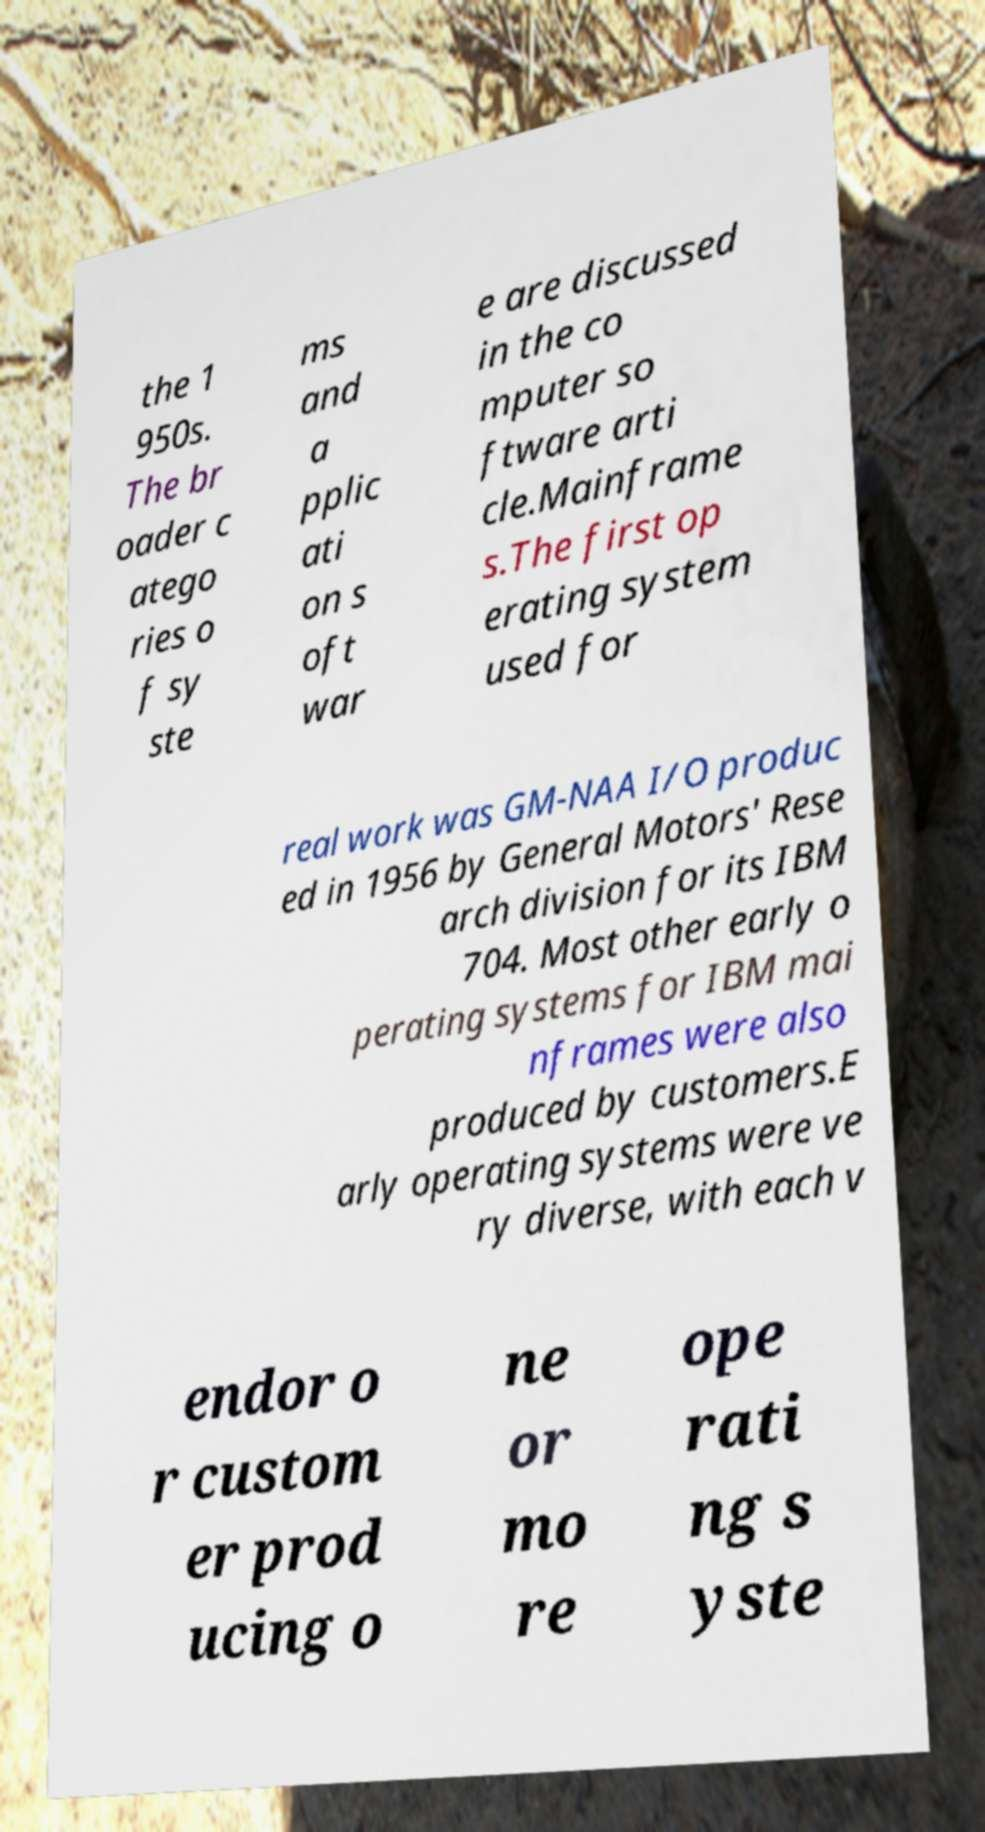There's text embedded in this image that I need extracted. Can you transcribe it verbatim? the 1 950s. The br oader c atego ries o f sy ste ms and a pplic ati on s oft war e are discussed in the co mputer so ftware arti cle.Mainframe s.The first op erating system used for real work was GM-NAA I/O produc ed in 1956 by General Motors' Rese arch division for its IBM 704. Most other early o perating systems for IBM mai nframes were also produced by customers.E arly operating systems were ve ry diverse, with each v endor o r custom er prod ucing o ne or mo re ope rati ng s yste 